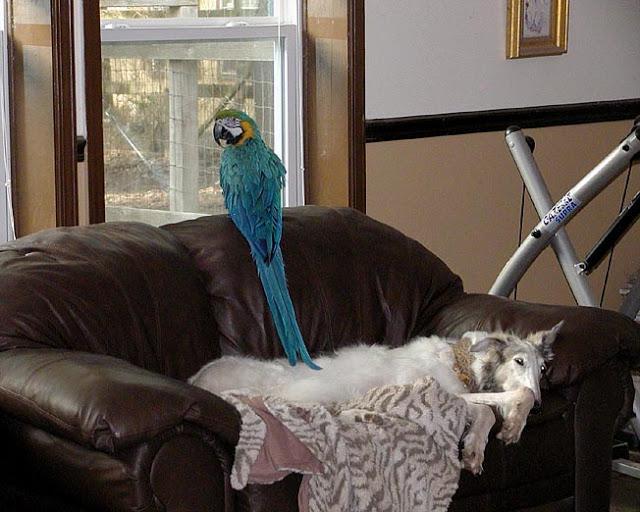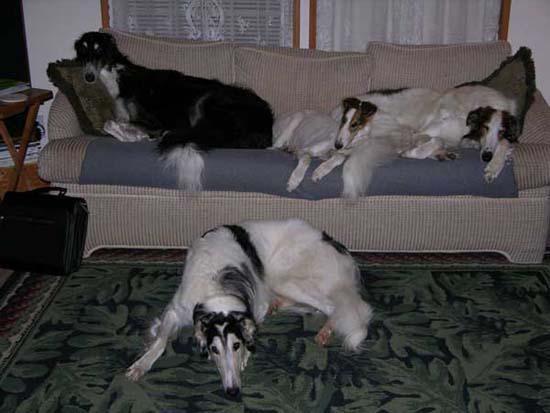The first image is the image on the left, the second image is the image on the right. For the images shown, is this caption "There are two dogs lying on the couch in the image on the right." true? Answer yes or no. Yes. The first image is the image on the left, the second image is the image on the right. For the images displayed, is the sentence "The right image contains at least two dogs laying down on a couch." factually correct? Answer yes or no. Yes. 